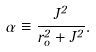Convert formula to latex. <formula><loc_0><loc_0><loc_500><loc_500>\alpha \equiv \frac { { J ^ { 2 } } } { r _ { o } ^ { 2 } + J ^ { 2 } } .</formula> 